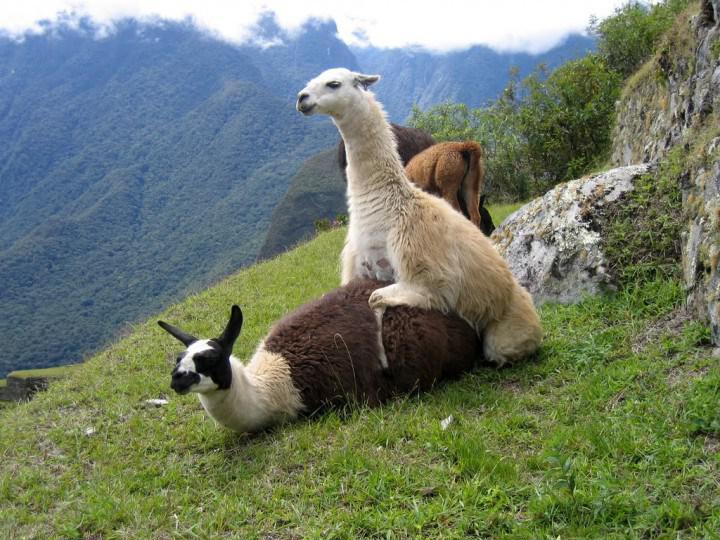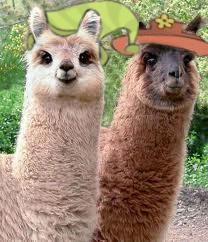The first image is the image on the left, the second image is the image on the right. Analyze the images presented: Is the assertion "The left and right image contains three llamas." valid? Answer yes or no. No. 